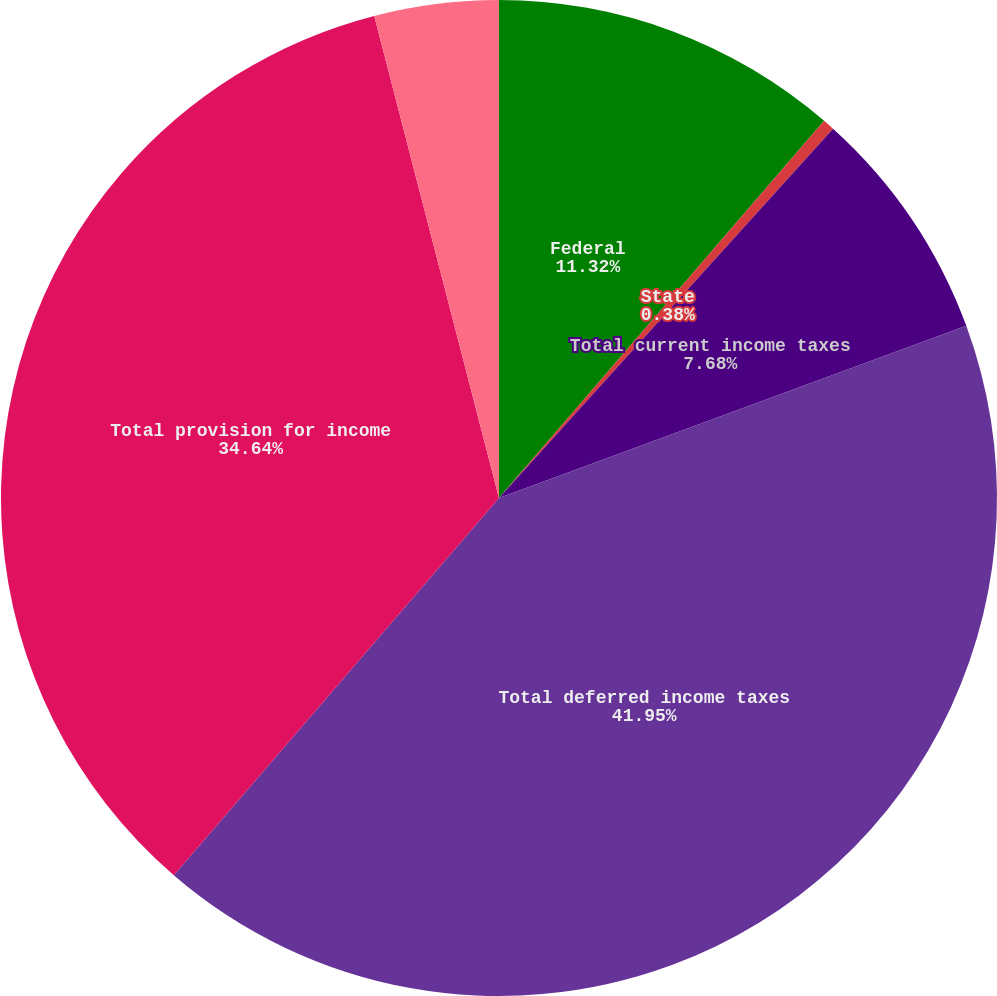Convert chart. <chart><loc_0><loc_0><loc_500><loc_500><pie_chart><fcel>Federal<fcel>State<fcel>Total current income taxes<fcel>Total deferred income taxes<fcel>Total provision for income<fcel>Discontinued operations<nl><fcel>11.32%<fcel>0.38%<fcel>7.68%<fcel>41.94%<fcel>34.64%<fcel>4.03%<nl></chart> 